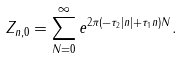<formula> <loc_0><loc_0><loc_500><loc_500>Z _ { n , 0 } = \sum _ { N = 0 } ^ { \infty } e ^ { 2 \pi ( - \tau _ { 2 } | n | + \tau _ { 1 } n ) N } .</formula> 